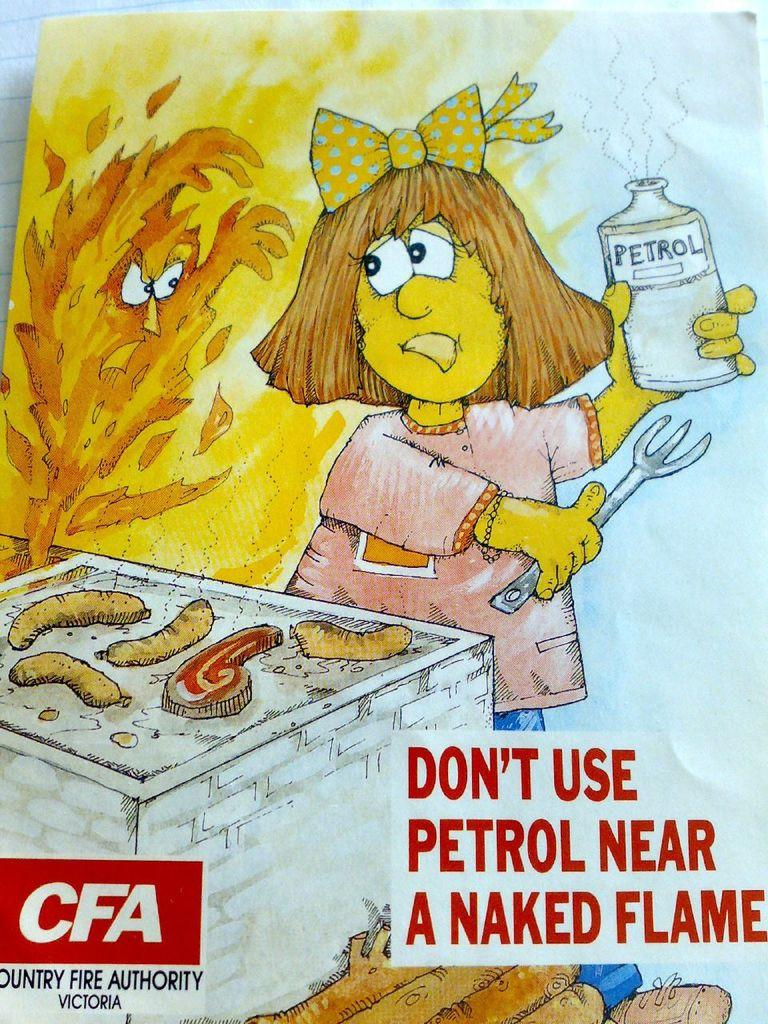What is the main subject of the image? The main subject of the image is a painting. Can you describe any additional features of the painting? There is text on the painting board. What action is the father taking with the tail in the image? There is no father or tail present in the image; it only features a painting with text on the painting board. 